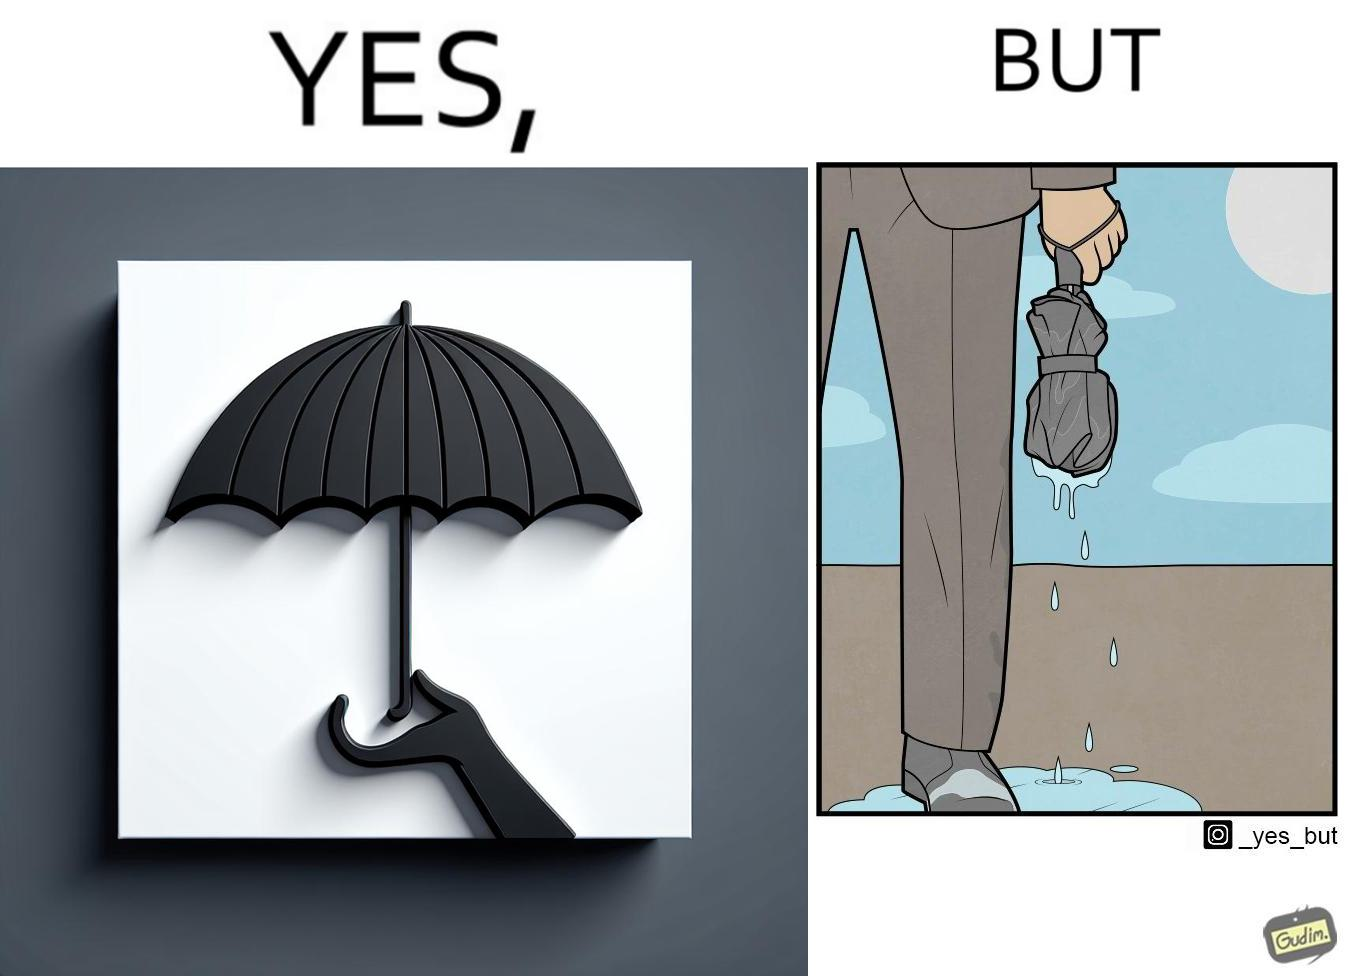Why is this image considered satirical? The image is funny because while the umbrella helps a person avoid getting wet from rain, when the rain stops and the umbrella is folded, the wet umbrella iteself drips water on the person holding it. 